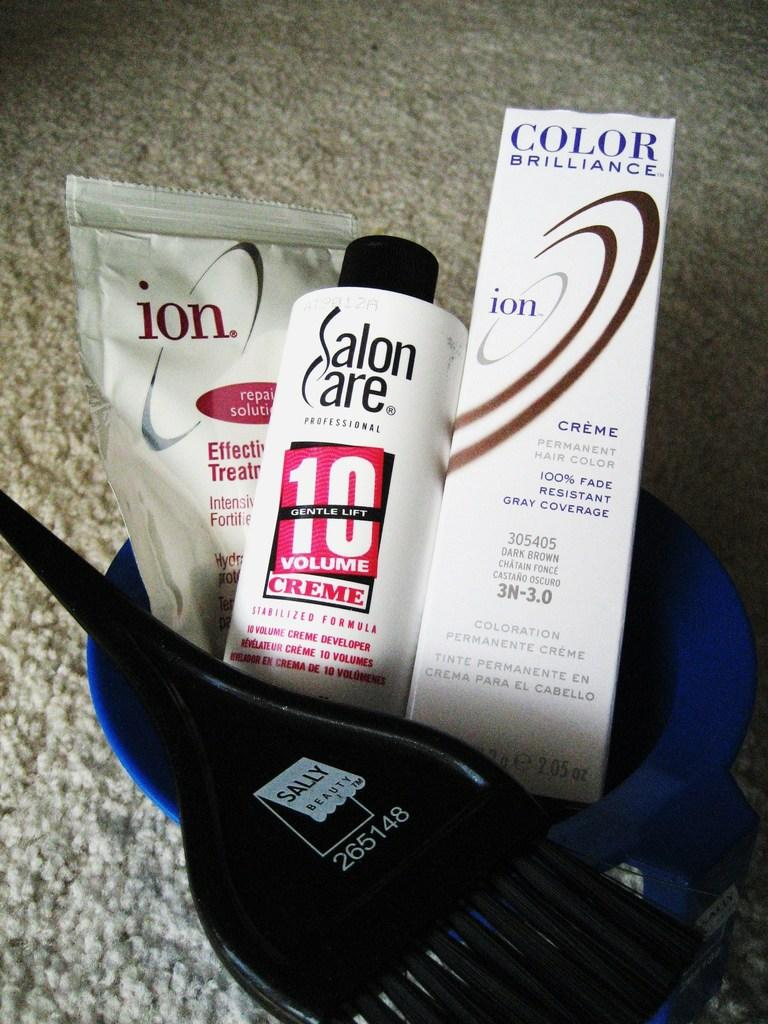Provide a one-sentence caption for the provided image. Face care products including a brush and a bottle saying Salon Care. 